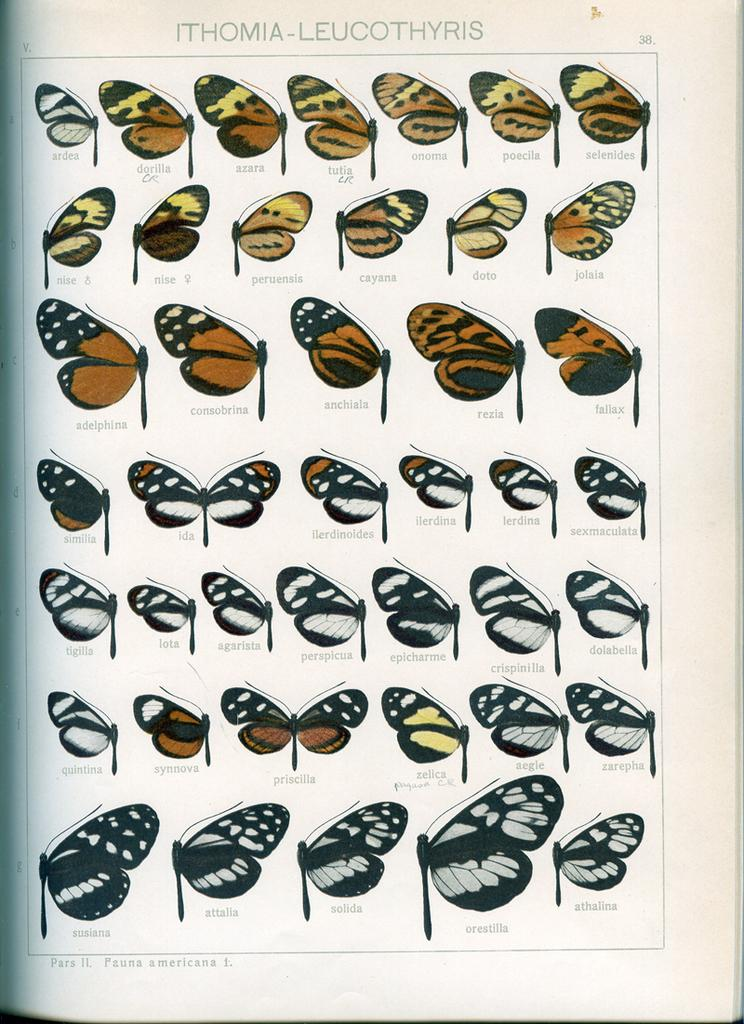What is the main subject of the image? The main subject of the image is a page, possibly from a book. What can be found on the page? There are various catalogs of butterflies in the image. Is there any text present in the image? Yes, there is text at the top of the image. What type of brick is being used to mark the page in the image? There is no brick present in the image, and the page is not marked with any object. Can you hear the cries of the butterflies in the image? Butterflies do not make audible cries, and there is no sound associated with the image. 